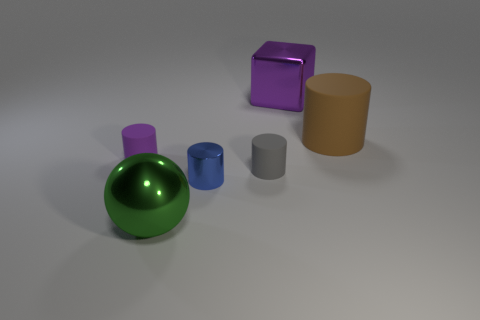From the image, what can you infer about the size of these objects? Without a reference for scale, it's difficult to ascertain the exact size, but if we assume the brown cylinder represents a typical canister, these objects could be small to medium-sized, easily fitting on a tabletop. 